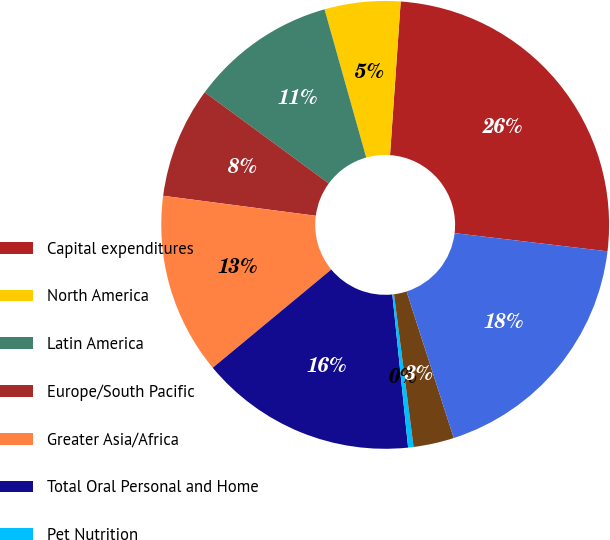Convert chart to OTSL. <chart><loc_0><loc_0><loc_500><loc_500><pie_chart><fcel>Capital expenditures<fcel>North America<fcel>Latin America<fcel>Europe/South Pacific<fcel>Greater Asia/Africa<fcel>Total Oral Personal and Home<fcel>Pet Nutrition<fcel>Corporate<fcel>Total Capital expenditures<nl><fcel>25.78%<fcel>5.47%<fcel>10.55%<fcel>8.01%<fcel>13.09%<fcel>15.62%<fcel>0.39%<fcel>2.93%<fcel>18.16%<nl></chart> 